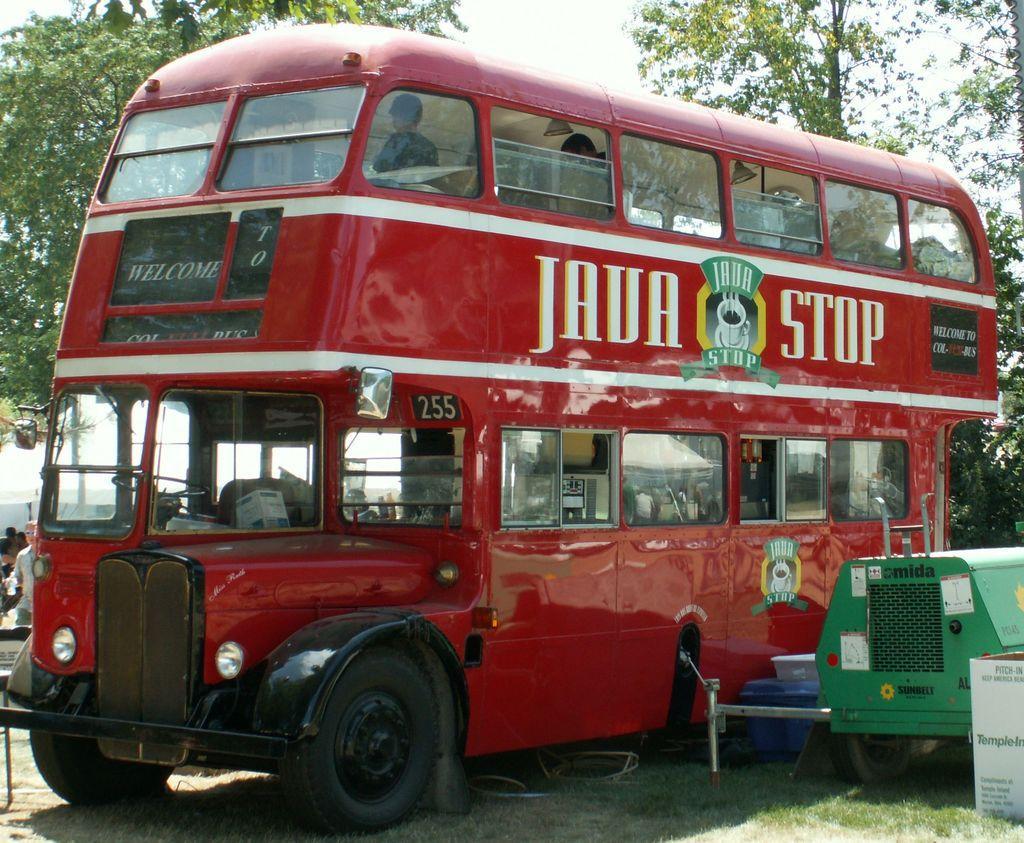Describe this image in one or two sentences. In this image, we can see a red color double decker bus, there is a vehicle on the right side. we can see some trees and the sky. 